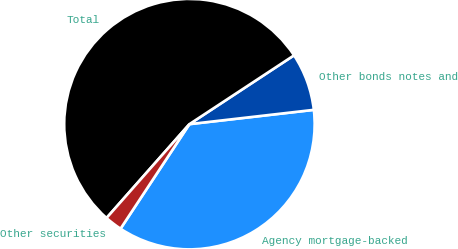<chart> <loc_0><loc_0><loc_500><loc_500><pie_chart><fcel>Agency mortgage-backed<fcel>Other bonds notes and<fcel>Total<fcel>Other securities<nl><fcel>36.1%<fcel>7.44%<fcel>54.23%<fcel>2.24%<nl></chart> 